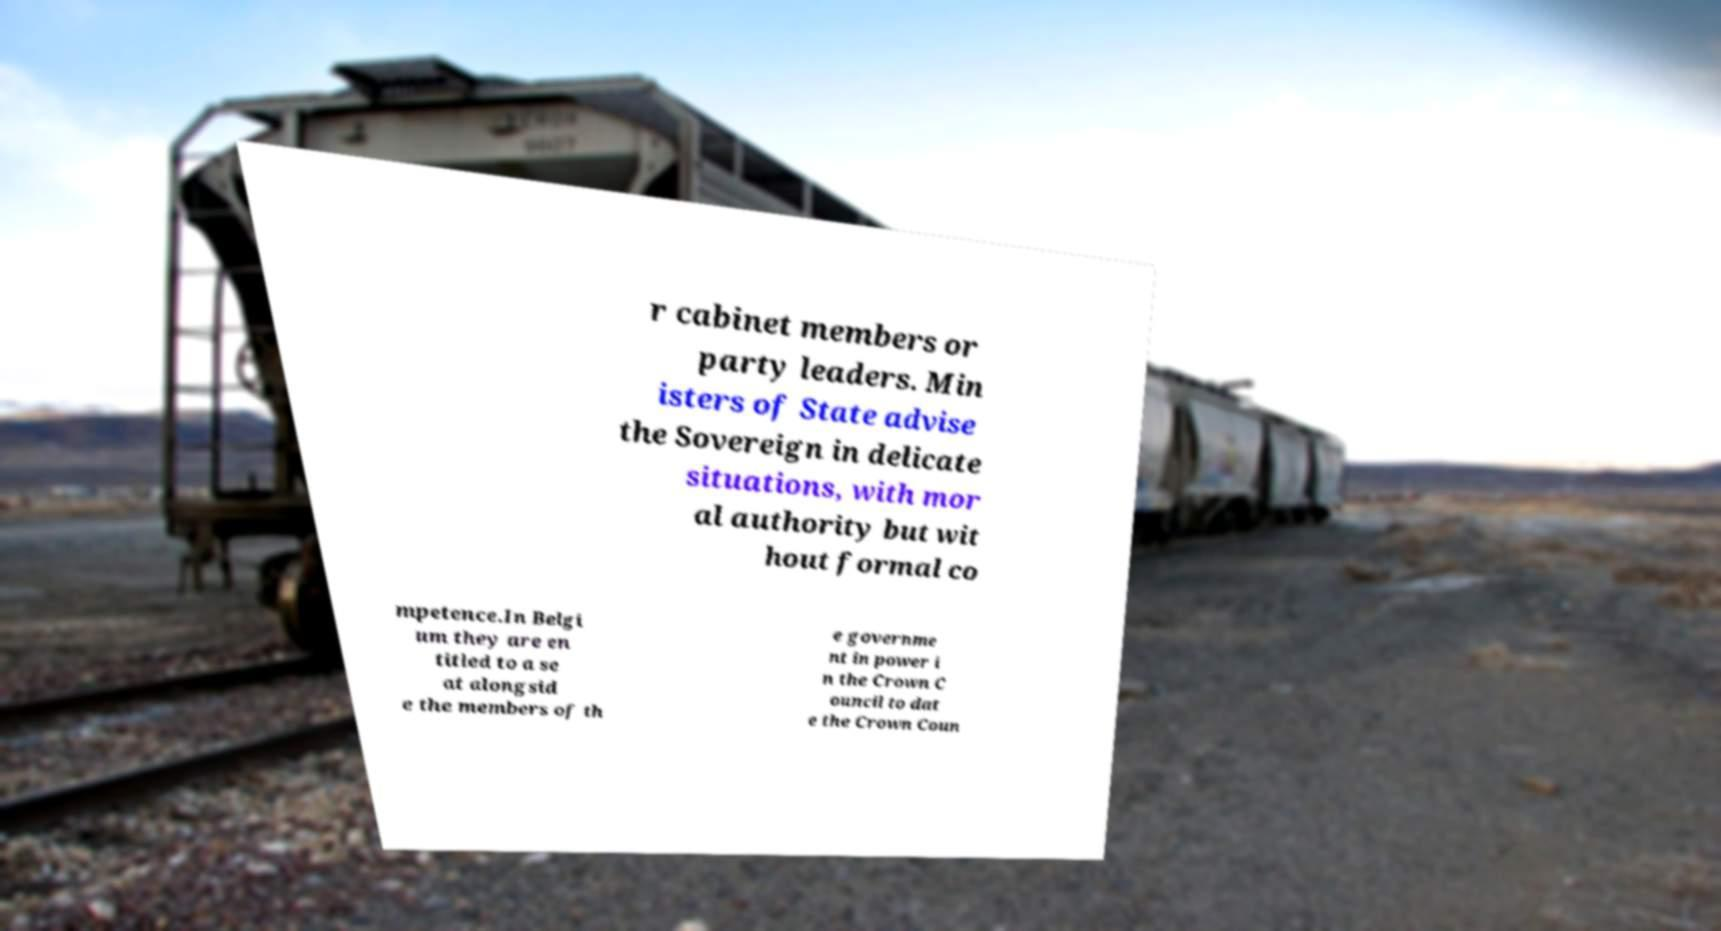Can you read and provide the text displayed in the image?This photo seems to have some interesting text. Can you extract and type it out for me? r cabinet members or party leaders. Min isters of State advise the Sovereign in delicate situations, with mor al authority but wit hout formal co mpetence.In Belgi um they are en titled to a se at alongsid e the members of th e governme nt in power i n the Crown C ouncil to dat e the Crown Coun 